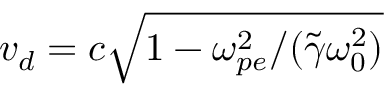<formula> <loc_0><loc_0><loc_500><loc_500>v _ { d } = c \sqrt { 1 - \omega _ { p e } ^ { 2 } / ( \tilde { \gamma } \omega _ { 0 } ^ { 2 } ) }</formula> 